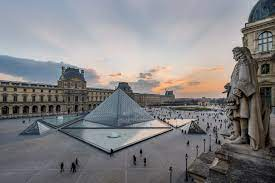What is this photo about'?
 The image captures a bustling scene at the Louvre Museum in Paris, France. The vantage point is high above the courtyard, providing a bird's eye view of the activity below. The courtyard is teeming with people, their colorful attire dotting the landscape. The centerpiece of the image is the large glass pyramid, a modern contrast to the historic Louvre buildings that surround it. This pyramid, along with several smaller ones, is reflected in a pool of water, adding a sense of symmetry to the scene. The grand buildings of the Louvre, with their classic architecture, form a semi-circle around the courtyard. The dome of the Louvre, a prominent feature of the museum, can be seen in the top right corner of the image. The sky above is a clear blue, with wispy clouds scattered across it, completing this picturesque view of one of the world's most renowned landmarks. 